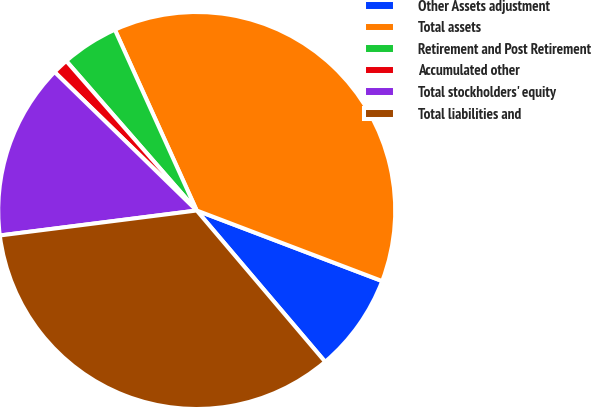Convert chart. <chart><loc_0><loc_0><loc_500><loc_500><pie_chart><fcel>Other Assets adjustment<fcel>Total assets<fcel>Retirement and Post Retirement<fcel>Accumulated other<fcel>Total stockholders' equity<fcel>Total liabilities and<nl><fcel>8.01%<fcel>37.55%<fcel>4.65%<fcel>1.29%<fcel>14.3%<fcel>34.19%<nl></chart> 